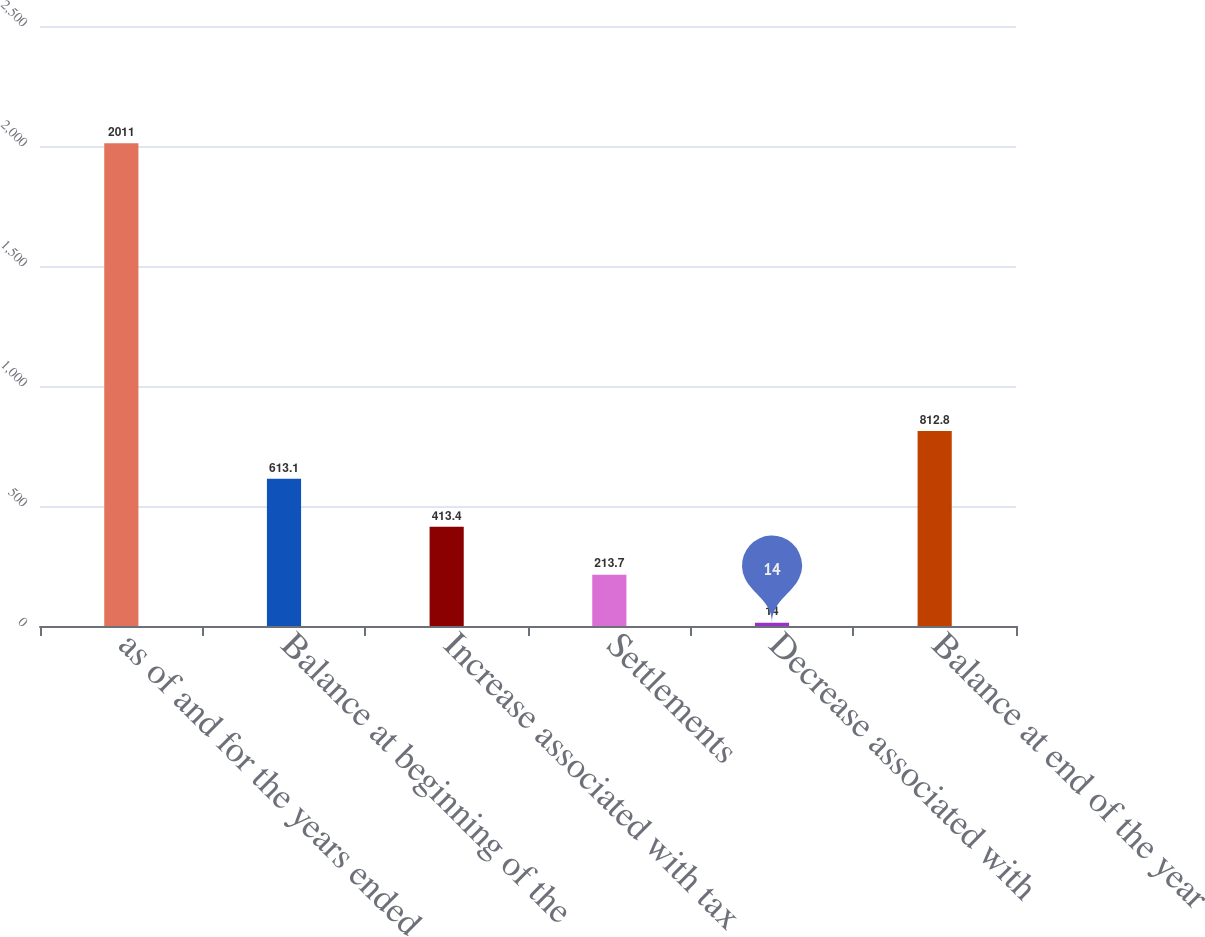Convert chart. <chart><loc_0><loc_0><loc_500><loc_500><bar_chart><fcel>as of and for the years ended<fcel>Balance at beginning of the<fcel>Increase associated with tax<fcel>Settlements<fcel>Decrease associated with<fcel>Balance at end of the year<nl><fcel>2011<fcel>613.1<fcel>413.4<fcel>213.7<fcel>14<fcel>812.8<nl></chart> 